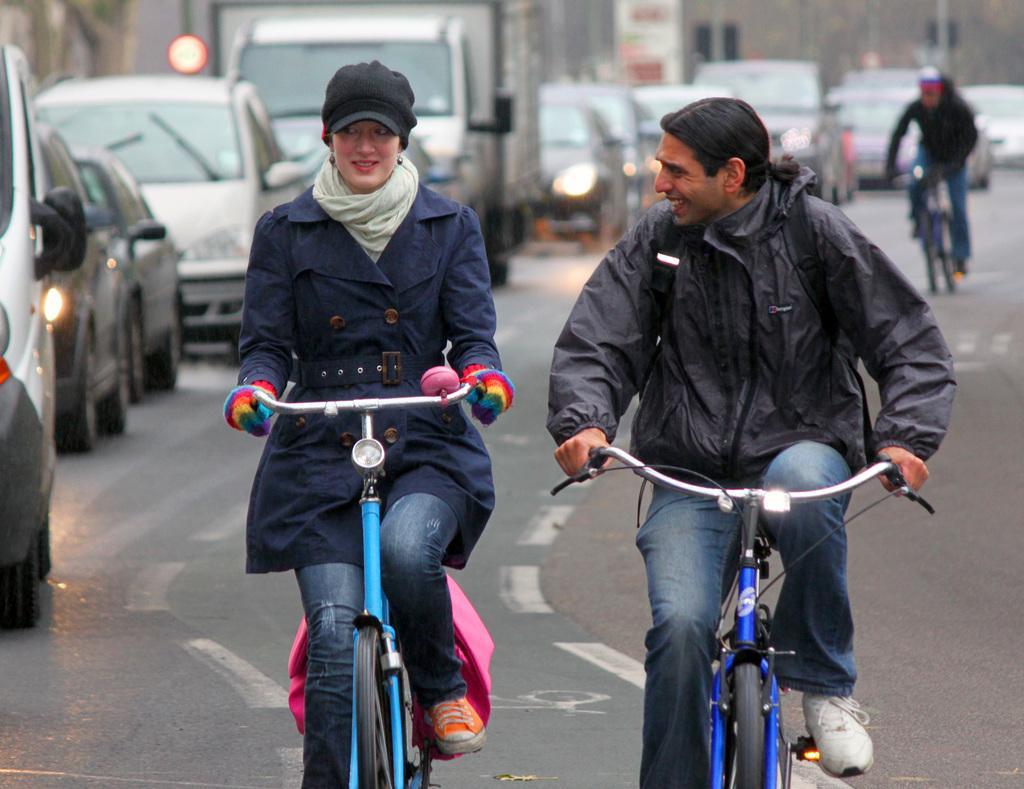In one or two sentences, can you explain what this image depicts? There is a man and woman riding bicycle behind under the other person riding bicycle and some cars parked on the road. 